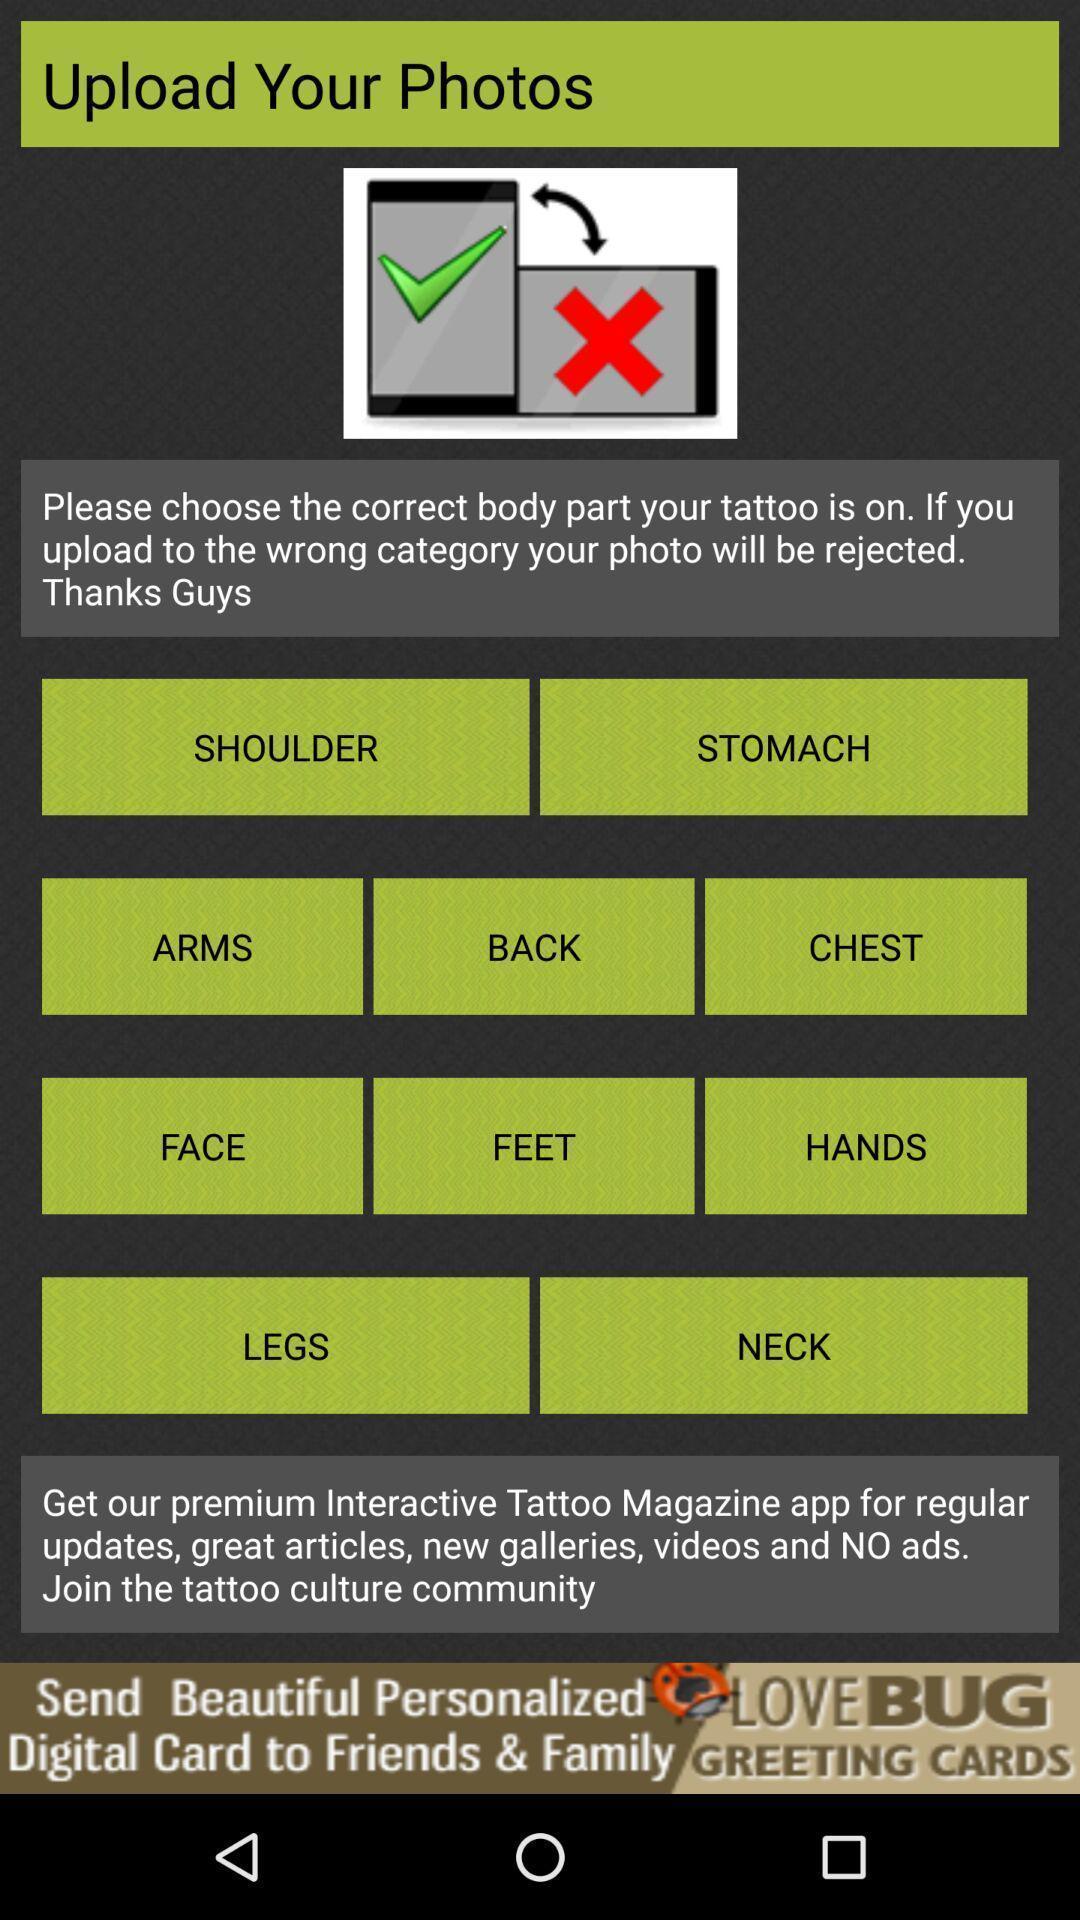Explain what's happening in this screen capture. Page to upload pictures for tattoo. 